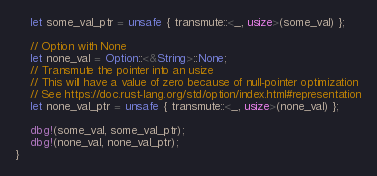Convert code to text. <code><loc_0><loc_0><loc_500><loc_500><_Rust_>    let some_val_ptr = unsafe { transmute::<_, usize>(some_val) };

    // Option with None
    let none_val = Option::<&String>::None;
    // Transmute the pointer into an usize
    // This will have a value of zero because of null-pointer optimization
    // See https://doc.rust-lang.org/std/option/index.html#representation
    let none_val_ptr = unsafe { transmute::<_, usize>(none_val) };

    dbg!(some_val, some_val_ptr);
    dbg!(none_val, none_val_ptr);
}
</code> 